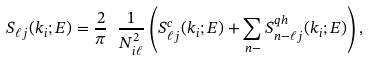<formula> <loc_0><loc_0><loc_500><loc_500>S _ { \ell j } ( k _ { i } ; E ) = \frac { 2 } { \pi } \ \frac { 1 } { N _ { i \ell } ^ { 2 } } \left ( S ^ { c } _ { \ell j } ( k _ { i } ; E ) + \sum _ { n - } S ^ { q h } _ { n - \ell j } ( k _ { i } ; E ) \right ) ,</formula> 